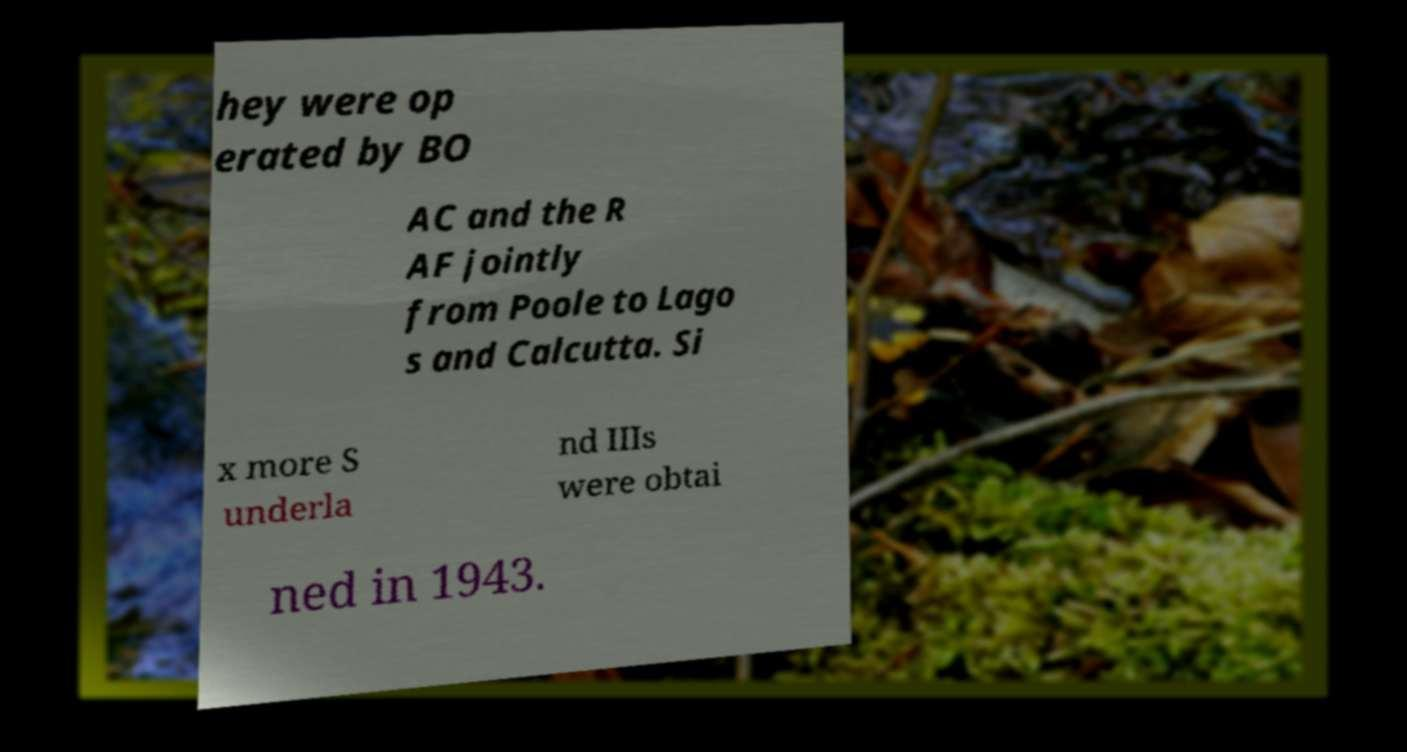There's text embedded in this image that I need extracted. Can you transcribe it verbatim? hey were op erated by BO AC and the R AF jointly from Poole to Lago s and Calcutta. Si x more S underla nd IIIs were obtai ned in 1943. 